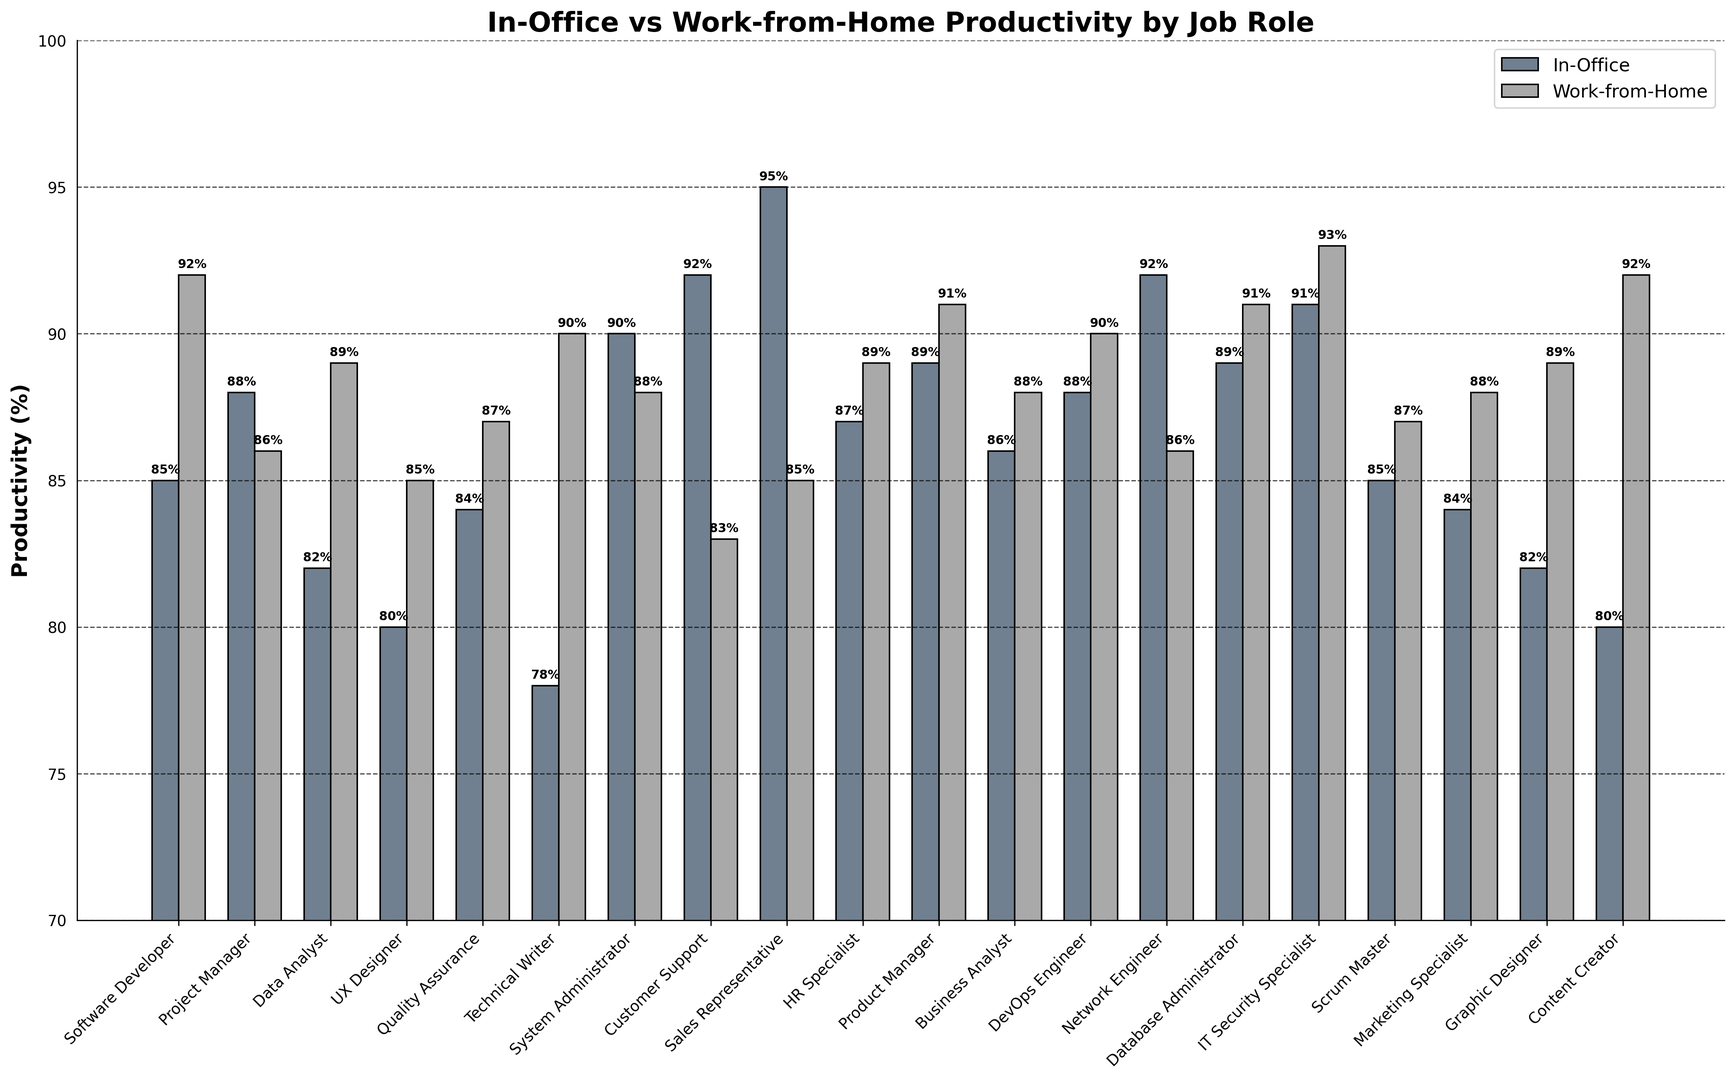Which job role has the highest work-from-home productivity? The heights of the bars represent the productivity percentages. The Technical Writer and Content Creator roles have the tallest bars, indicating 90% productivity for Technical Writer and 92% for Content Creator. Content Creator is higher.
Answer: Content Creator Which job role has the largest decrease in productivity when working from home compared to in office? Calculate the difference between in-office and work-from-home productivity for each job role and find the largest negative difference. Customer Support has a 9% decrease (92% in-office vs 83% work-from-home).
Answer: Customer Support What is the average work-from-home productivity rate across all job roles? Sum all work-from-home productivity rates and divide by the number of job roles: (92 + 86 + 89 + 85 + 87 + 90 + 88 + 83 + 85 + 89 + 91 + 88 + 90 + 86 + 91 + 93 + 87 + 88 + 89 + 92) / 20 = 87.9.
Answer: 87.9% Compare the in-office productivity between Data Analyst and Database Administrator. Identify the bar heights for each role. Data Analyst has 82%, and Database Administrator has 89%, so the Database Administrator's productivity is higher in-office.
Answer: Database Administrator Which job roles have a higher productivity at work-from-home than in-office? Check for bars where the work-from-home height exceeds the in-office height. Software Developer (92% vs 85%), Data Analyst (89% vs 82%), UX Designer (85% vs 80%), Quality Assurance (87% vs 84%), Technical Writer (90% vs 78%), HR Specialist (89% vs 87%), Product Manager (91% vs 89%), Database Administrator (91% vs 89%), IT Security Specialist (93% vs 91%), DevOps Engineer (90% vs 88%), Marketing Specialist (88% vs 84%), Graphic Designer (89% vs 82%), Content Creator (92% vs 80%).
Answer: 13 roles What is the total productivity (sum) for In-Office and Work-from-Home for the Marketing Specialist role? Sum the in-office and work-from-home productivity percentages for Marketing Specialist: 84% (in-office) + 88% (work-from-home) = 172%.
Answer: 172% 